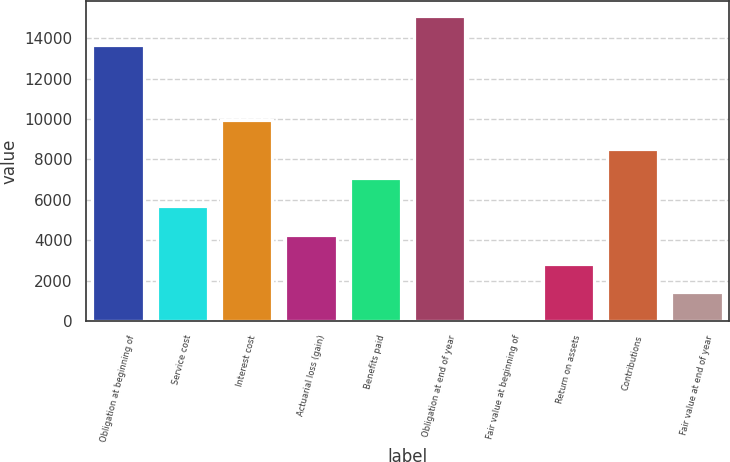Convert chart. <chart><loc_0><loc_0><loc_500><loc_500><bar_chart><fcel>Obligation at beginning of<fcel>Service cost<fcel>Interest cost<fcel>Actuarial loss (gain)<fcel>Benefits paid<fcel>Obligation at end of year<fcel>Fair value at beginning of<fcel>Return on assets<fcel>Contributions<fcel>Fair value at end of year<nl><fcel>13680<fcel>5681.67<fcel>9942.84<fcel>4261.28<fcel>7102.06<fcel>15100.4<fcel>0.11<fcel>2840.89<fcel>8522.45<fcel>1420.5<nl></chart> 